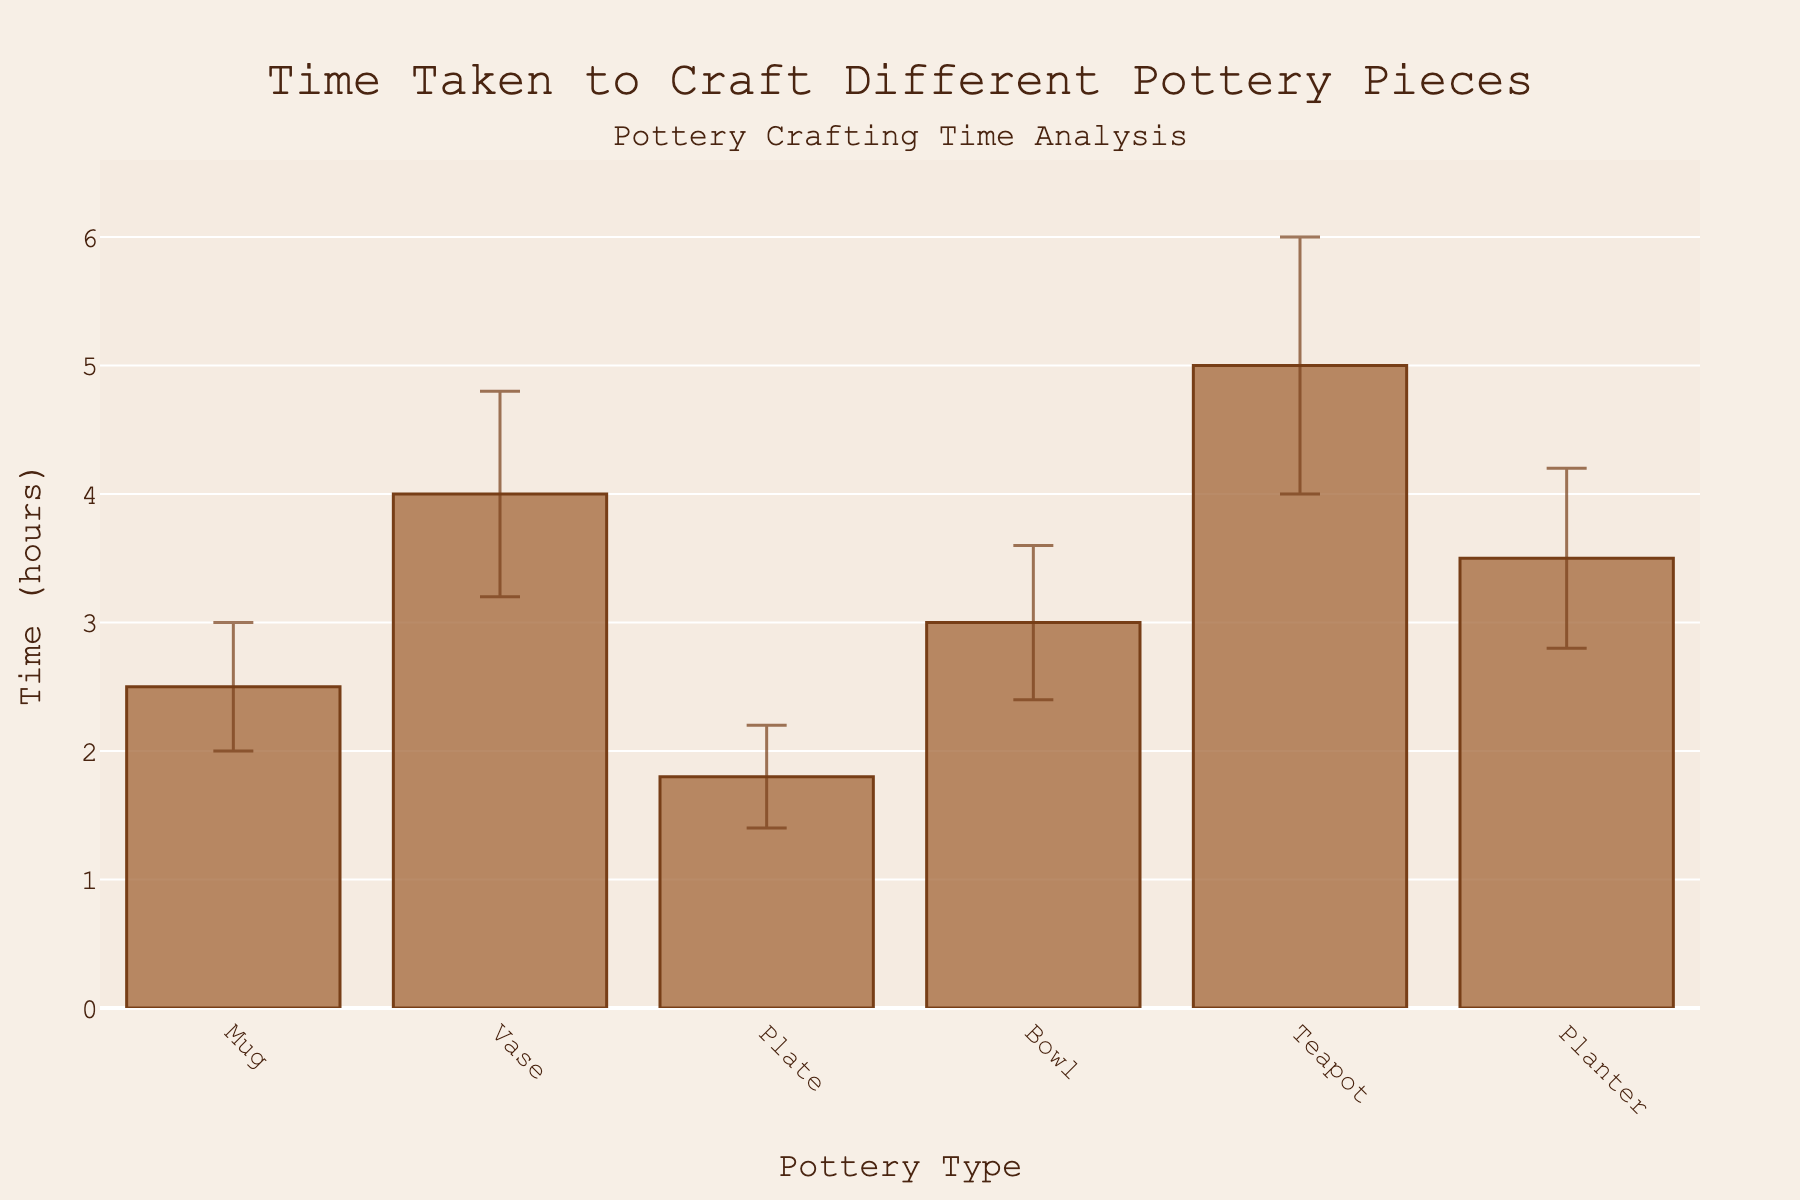What is the average time taken to craft a teapot? The figure shows the specific average crafting time for each pottery type on the y-axis. Locate the bar corresponding to the teapot and read the average value.
Answer: 5.0 hours What are the x-axis and y-axis titles indicating? The x-axis represents different pottery types, and the y-axis shows the time taken to craft in hours. This is stated by the axis titles in the figure.
Answer: Pottery Type, Time (hours) Which pottery piece takes the least average time to craft? Analyze each bar's height to determine which one is the shortest. The plate has the shortest bar, indicating it takes the least time.
Answer: Plate What is the average error range for crafting a vase? Identify the vertical error bar on top of the vase's bar, and read the range indicated.
Answer: 0.8 hours What is the difference in average crafting time between a mug and a teapot? Find the average times for both the mug (2.5) and the teapot (5.0), then subtract the mug's time from the teapot's time.
Answer: 2.5 hours Which pottery type has the widest error range in crafting time? Compare the heights of the error bars for all pottery types. The teapot's error bar is the tallest, indicating the widest range.
Answer: Teapot How does the crafting time variability of a planter compare to a bowl? Look at the error bars for both the planter and bowl. The planter’s error range is 0.7 hours, while the bowl’s range is 0.6 hours, indicating the planter has slightly more variability.
Answer: Planter has more variability What is the combined average crafting time for a mug and a vase? Add the average times of both the mug (2.5) and the vase (4.0) to find the total.
Answer: 6.5 hours Which pottery type shows the smallest variability in crafting time? Identify which error bar is the shortest. The plate's error bar is the smallest, indicating the smallest variability.
Answer: Plate Is the crafting time for a bowl closer to that of a mug or a vase? Compare the average times. The bowl's average is 3.0 hours, the mug is 2.5 hours, and the vase is 4.0 hours. Since 3.0 is closer to 2.5, the bowl's crafting time is closer to the mug.
Answer: Mug 